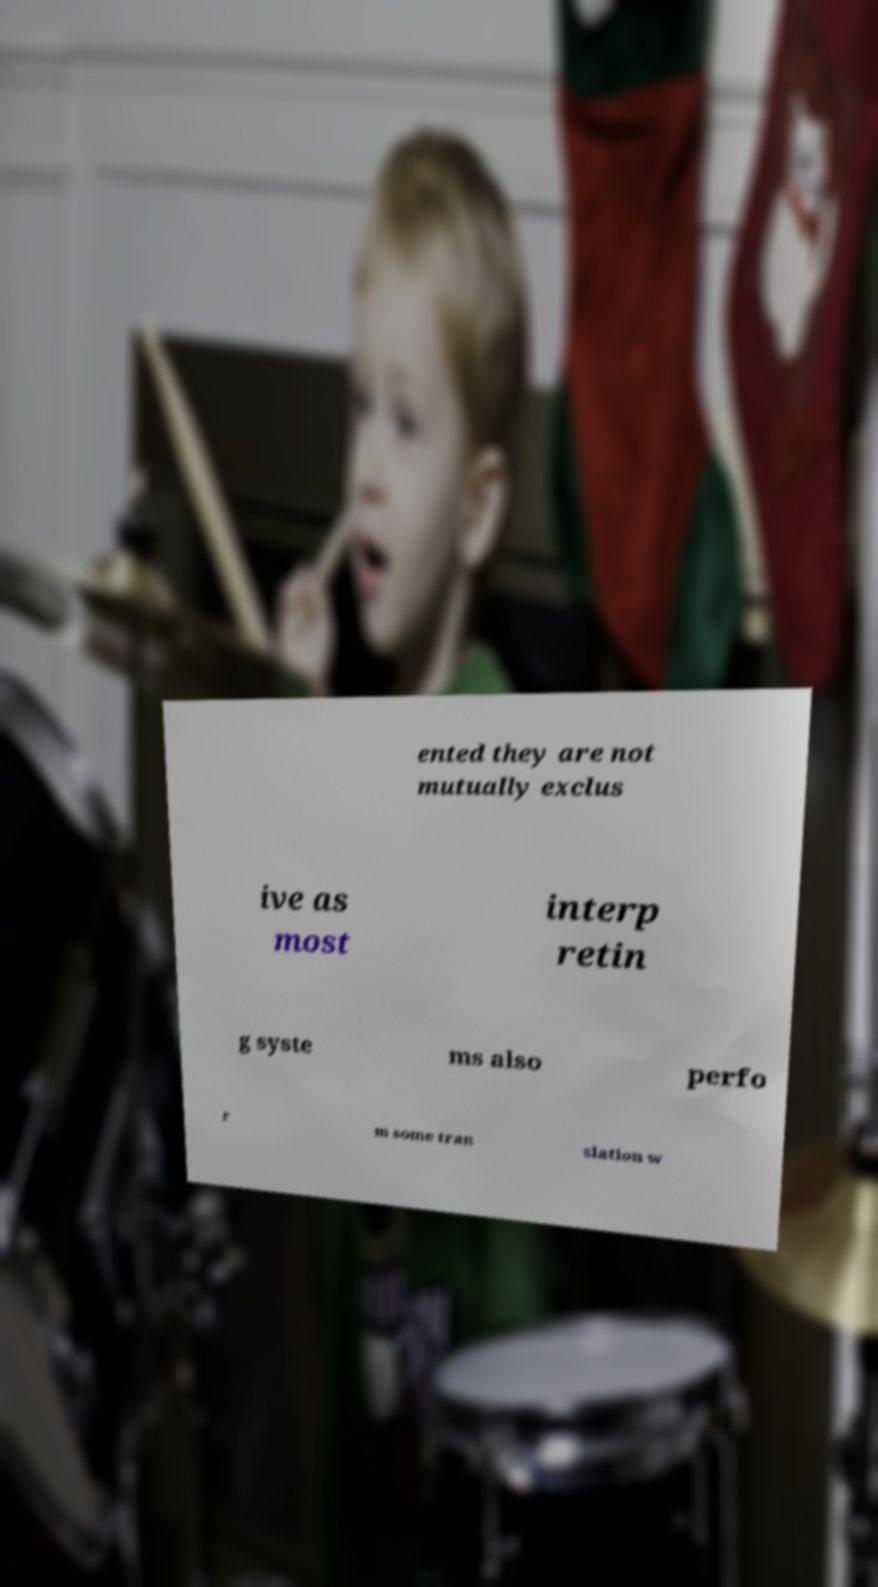Could you assist in decoding the text presented in this image and type it out clearly? ented they are not mutually exclus ive as most interp retin g syste ms also perfo r m some tran slation w 